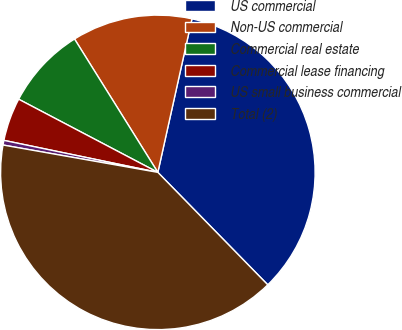Convert chart to OTSL. <chart><loc_0><loc_0><loc_500><loc_500><pie_chart><fcel>US commercial<fcel>Non-US commercial<fcel>Commercial real estate<fcel>Commercial lease financing<fcel>US small business commercial<fcel>Total (2)<nl><fcel>34.2%<fcel>12.37%<fcel>8.41%<fcel>4.44%<fcel>0.48%<fcel>40.1%<nl></chart> 